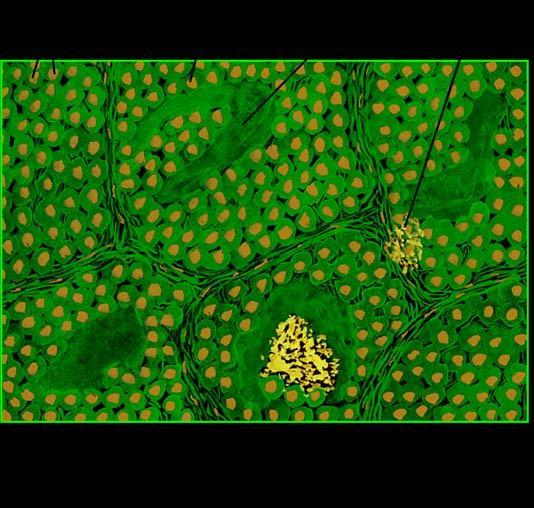does a show organoid pattern of oval tumour cells and abundant amyloid stroma?
Answer the question using a single word or phrase. No 